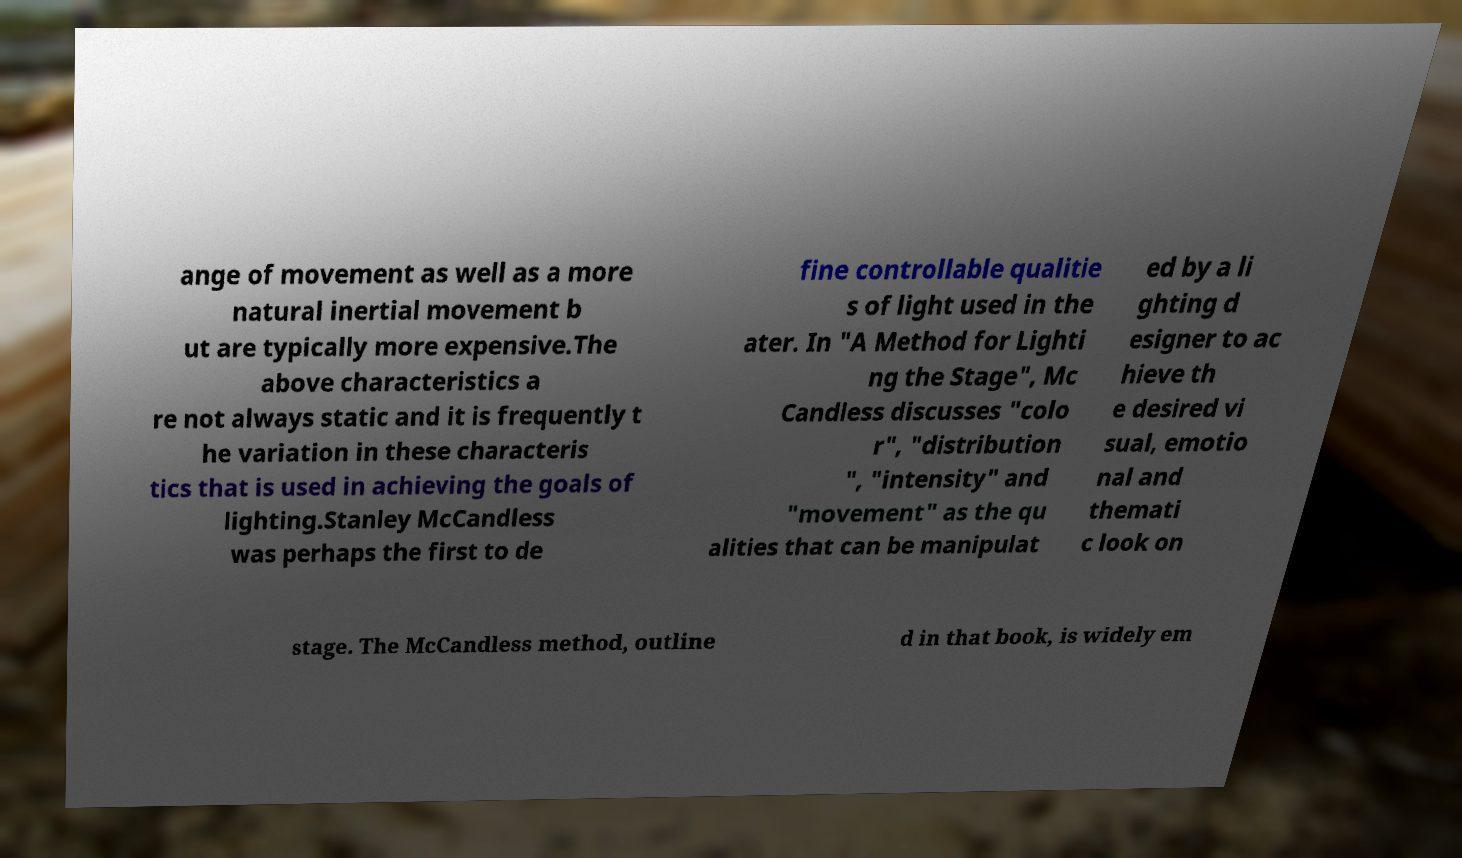Please identify and transcribe the text found in this image. ange of movement as well as a more natural inertial movement b ut are typically more expensive.The above characteristics a re not always static and it is frequently t he variation in these characteris tics that is used in achieving the goals of lighting.Stanley McCandless was perhaps the first to de fine controllable qualitie s of light used in the ater. In "A Method for Lighti ng the Stage", Mc Candless discusses "colo r", "distribution ", "intensity" and "movement" as the qu alities that can be manipulat ed by a li ghting d esigner to ac hieve th e desired vi sual, emotio nal and themati c look on stage. The McCandless method, outline d in that book, is widely em 